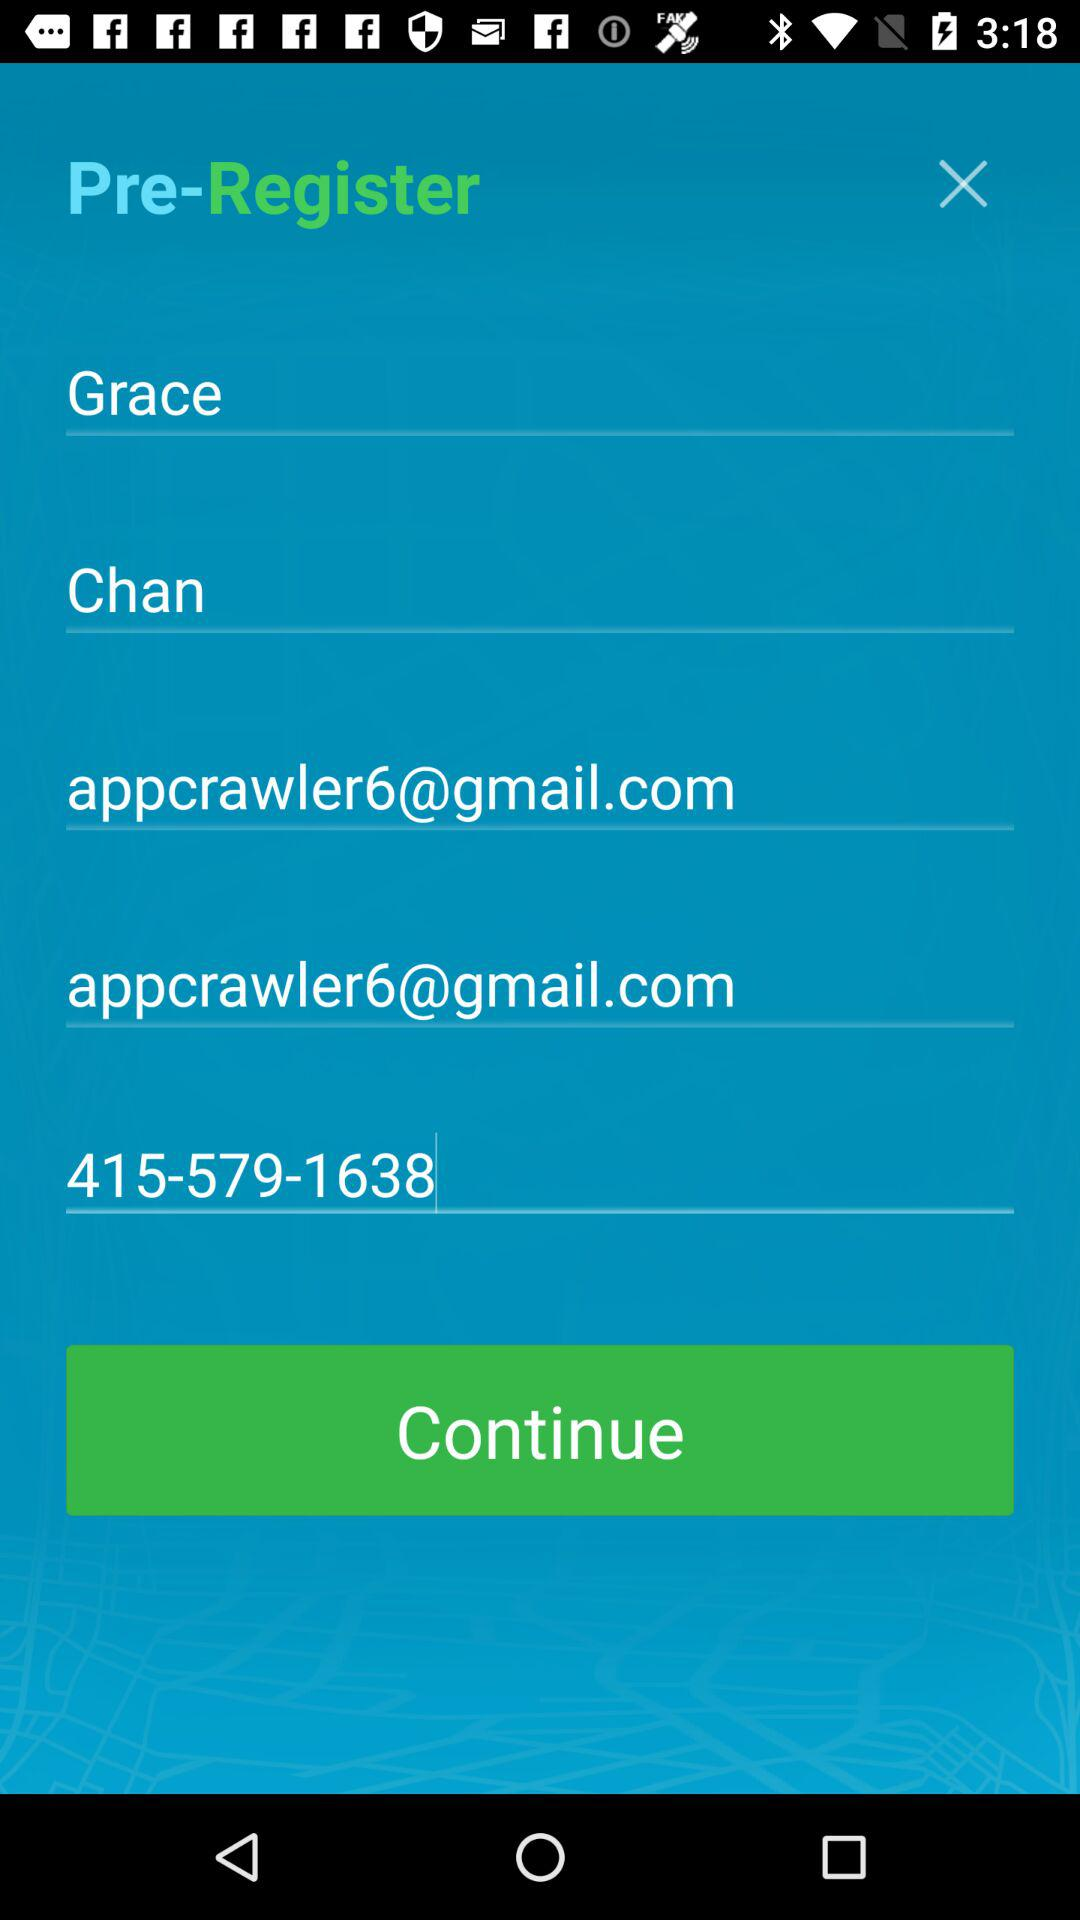What is the last name of the user? The last name of the user is Chan. 